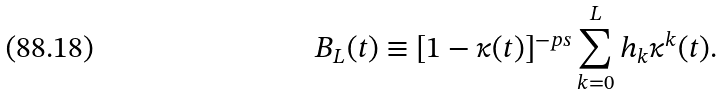Convert formula to latex. <formula><loc_0><loc_0><loc_500><loc_500>B _ { L } ( t ) \equiv [ 1 - \kappa ( t ) ] ^ { - p s } \sum _ { k = 0 } ^ { L } h _ { k } \kappa ^ { k } ( t ) .</formula> 